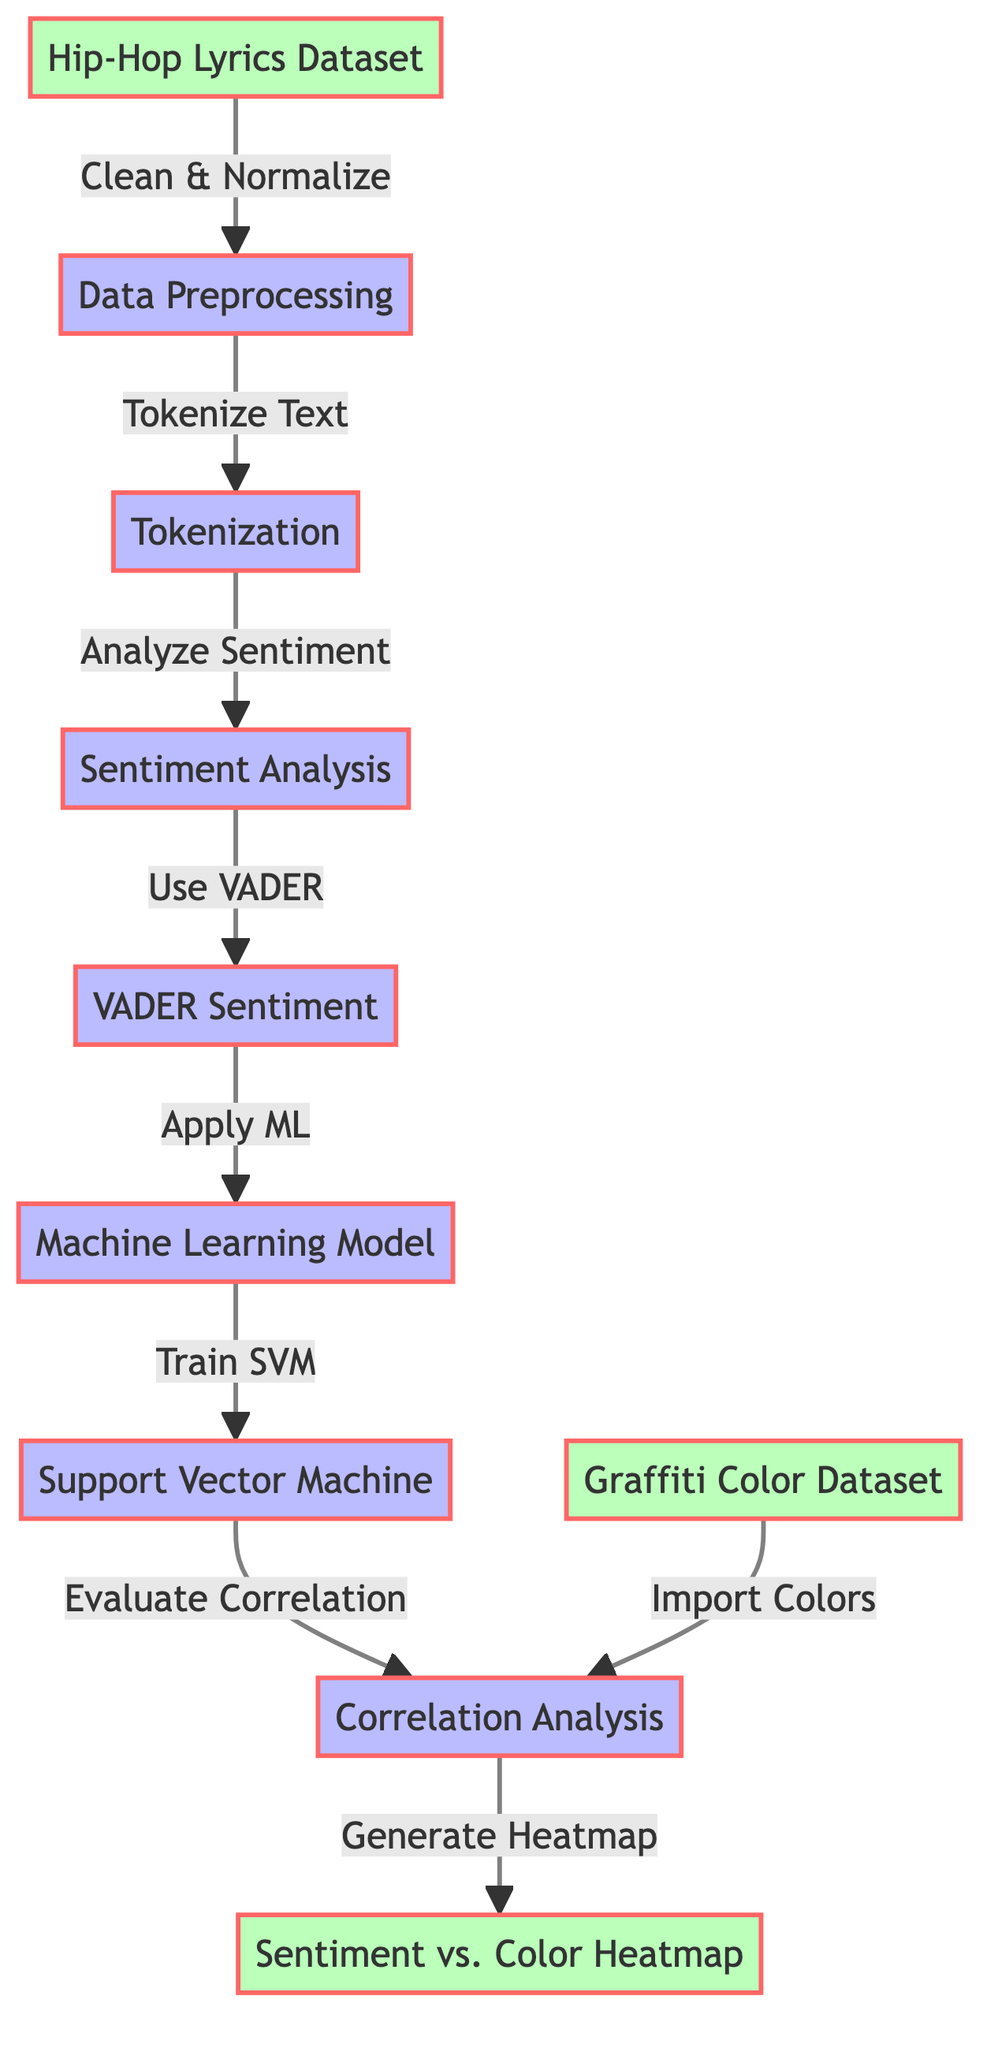What is the first stage of the process? The first stage of the process is labeled as "Hip-Hop Lyrics Dataset" which indicates where the data input begins.
Answer: Hip-Hop Lyrics Dataset How many main processes are there in this diagram? Counting the main process nodes: Data Preprocessing, Tokenization, Sentiment Analysis, Machine Learning Model, Correlation Analysis, the total is five processes.
Answer: Five Which sentiment analysis tool is used in the diagram? The diagram specifies that the "VADER Sentiment" tool is used for analyzing sentiment within the depicted processes.
Answer: VADER Sentiment What does the output of the "Correlation Analysis" provide? The Correlation Analysis leads to generating a heatmap that visualizes the relationship between sentiment and graffiti colors, showing how they correlate.
Answer: Heatmap What type of machine learning model is mentioned? The Machine Learning model utilized in this process is described as a "Support Vector Machine."
Answer: Support Vector Machine How does data flow from the "Tokenization" node? The data flows from Tokenization to Sentiment Analysis, signifying that after tokenizing, the next step is to analyze sentiment based on the tokenized text.
Answer: Sentiment Analysis What is the relationship between the two datasets in the correlation analysis? The correlation analysis node shows that it imports colors from the "Graffiti Color Dataset," indicating a necessary relationship between the sentiment analysis and the chosen colors.
Answer: Import Colors What do the arrows represent in this diagram? The arrows in this diagram represent the flow of the data and processes from one stage to another, indicating the direction of operation and dependencies among nodes.
Answer: Flow of data What is the last step of the process in the diagram? The final step indicated in the diagram is the generation of the "Sentiment vs. Color Heatmap," which visualizes the findings of the analysis conducted in earlier stages.
Answer: Sentiment vs. Color Heatmap 